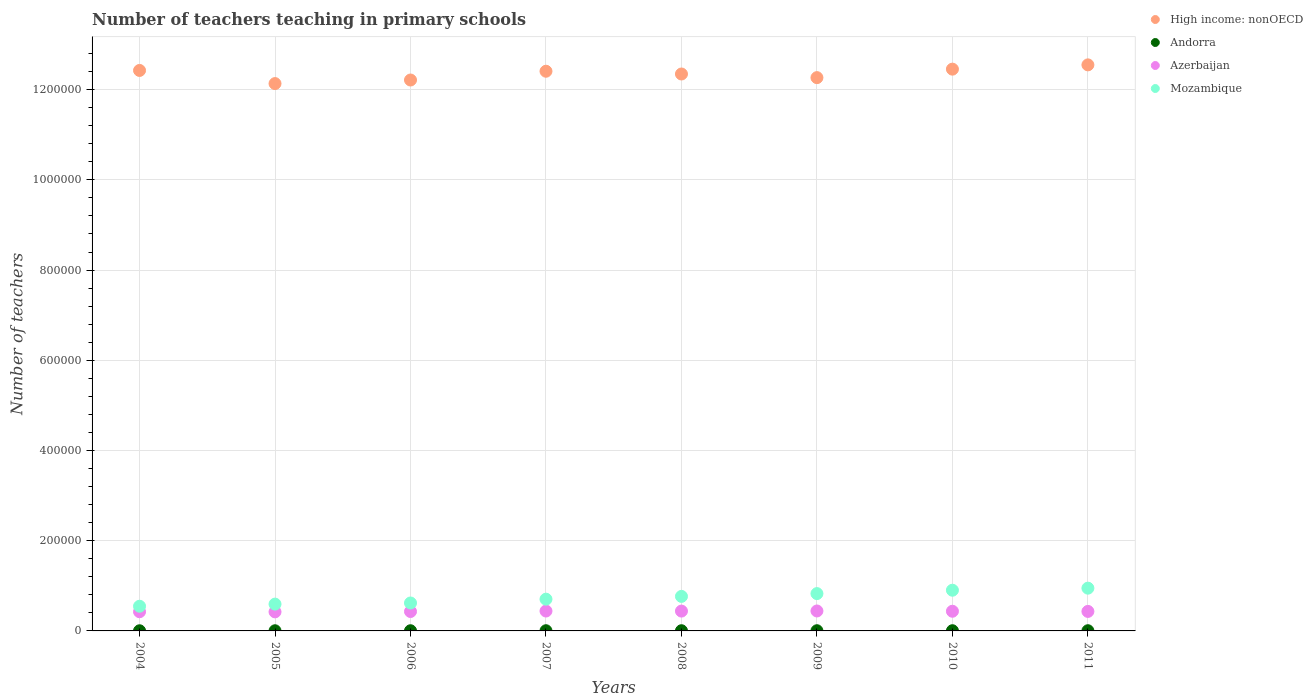How many different coloured dotlines are there?
Provide a short and direct response. 4. Is the number of dotlines equal to the number of legend labels?
Your response must be concise. Yes. What is the number of teachers teaching in primary schools in High income: nonOECD in 2010?
Offer a very short reply. 1.25e+06. Across all years, what is the maximum number of teachers teaching in primary schools in Andorra?
Provide a short and direct response. 453. Across all years, what is the minimum number of teachers teaching in primary schools in Andorra?
Your answer should be compact. 337. In which year was the number of teachers teaching in primary schools in Azerbaijan maximum?
Your answer should be very brief. 2009. In which year was the number of teachers teaching in primary schools in Mozambique minimum?
Provide a succinct answer. 2004. What is the total number of teachers teaching in primary schools in High income: nonOECD in the graph?
Offer a terse response. 9.88e+06. What is the difference between the number of teachers teaching in primary schools in High income: nonOECD in 2005 and that in 2009?
Provide a succinct answer. -1.32e+04. What is the difference between the number of teachers teaching in primary schools in Andorra in 2006 and the number of teachers teaching in primary schools in Azerbaijan in 2004?
Offer a very short reply. -4.21e+04. What is the average number of teachers teaching in primary schools in Azerbaijan per year?
Provide a short and direct response. 4.34e+04. In the year 2007, what is the difference between the number of teachers teaching in primary schools in Mozambique and number of teachers teaching in primary schools in Azerbaijan?
Provide a succinct answer. 2.63e+04. What is the ratio of the number of teachers teaching in primary schools in Azerbaijan in 2004 to that in 2007?
Your answer should be compact. 0.96. What is the difference between the highest and the second highest number of teachers teaching in primary schools in Azerbaijan?
Ensure brevity in your answer.  126. What is the difference between the highest and the lowest number of teachers teaching in primary schools in Andorra?
Your answer should be very brief. 116. Is the sum of the number of teachers teaching in primary schools in Azerbaijan in 2008 and 2009 greater than the maximum number of teachers teaching in primary schools in Andorra across all years?
Your answer should be very brief. Yes. Does the number of teachers teaching in primary schools in Andorra monotonically increase over the years?
Provide a succinct answer. No. Is the number of teachers teaching in primary schools in High income: nonOECD strictly greater than the number of teachers teaching in primary schools in Azerbaijan over the years?
Offer a terse response. Yes. Does the graph contain any zero values?
Offer a very short reply. No. How are the legend labels stacked?
Your response must be concise. Vertical. What is the title of the graph?
Your answer should be compact. Number of teachers teaching in primary schools. What is the label or title of the Y-axis?
Offer a very short reply. Number of teachers. What is the Number of teachers of High income: nonOECD in 2004?
Provide a short and direct response. 1.24e+06. What is the Number of teachers in Andorra in 2004?
Provide a succinct answer. 337. What is the Number of teachers in Azerbaijan in 2004?
Provide a succinct answer. 4.25e+04. What is the Number of teachers of Mozambique in 2004?
Offer a very short reply. 5.47e+04. What is the Number of teachers in High income: nonOECD in 2005?
Offer a very short reply. 1.21e+06. What is the Number of teachers in Andorra in 2005?
Offer a very short reply. 356. What is the Number of teachers of Azerbaijan in 2005?
Provide a short and direct response. 4.22e+04. What is the Number of teachers of Mozambique in 2005?
Offer a very short reply. 5.94e+04. What is the Number of teachers of High income: nonOECD in 2006?
Your response must be concise. 1.22e+06. What is the Number of teachers in Andorra in 2006?
Provide a succinct answer. 413. What is the Number of teachers of Azerbaijan in 2006?
Keep it short and to the point. 4.30e+04. What is the Number of teachers of Mozambique in 2006?
Your response must be concise. 6.19e+04. What is the Number of teachers of High income: nonOECD in 2007?
Ensure brevity in your answer.  1.24e+06. What is the Number of teachers in Andorra in 2007?
Ensure brevity in your answer.  432. What is the Number of teachers in Azerbaijan in 2007?
Make the answer very short. 4.41e+04. What is the Number of teachers of Mozambique in 2007?
Your answer should be compact. 7.04e+04. What is the Number of teachers in High income: nonOECD in 2008?
Provide a short and direct response. 1.23e+06. What is the Number of teachers of Andorra in 2008?
Offer a terse response. 448. What is the Number of teachers in Azerbaijan in 2008?
Your answer should be compact. 4.40e+04. What is the Number of teachers in Mozambique in 2008?
Your answer should be compact. 7.66e+04. What is the Number of teachers of High income: nonOECD in 2009?
Your response must be concise. 1.23e+06. What is the Number of teachers in Andorra in 2009?
Offer a terse response. 433. What is the Number of teachers in Azerbaijan in 2009?
Provide a succinct answer. 4.42e+04. What is the Number of teachers of Mozambique in 2009?
Offer a terse response. 8.28e+04. What is the Number of teachers in High income: nonOECD in 2010?
Give a very brief answer. 1.25e+06. What is the Number of teachers of Andorra in 2010?
Your response must be concise. 453. What is the Number of teachers in Azerbaijan in 2010?
Make the answer very short. 4.36e+04. What is the Number of teachers of Mozambique in 2010?
Offer a terse response. 9.02e+04. What is the Number of teachers of High income: nonOECD in 2011?
Your answer should be very brief. 1.25e+06. What is the Number of teachers of Andorra in 2011?
Your answer should be compact. 433. What is the Number of teachers in Azerbaijan in 2011?
Your answer should be compact. 4.32e+04. What is the Number of teachers in Mozambique in 2011?
Offer a terse response. 9.48e+04. Across all years, what is the maximum Number of teachers of High income: nonOECD?
Provide a short and direct response. 1.25e+06. Across all years, what is the maximum Number of teachers in Andorra?
Your response must be concise. 453. Across all years, what is the maximum Number of teachers in Azerbaijan?
Make the answer very short. 4.42e+04. Across all years, what is the maximum Number of teachers in Mozambique?
Your answer should be very brief. 9.48e+04. Across all years, what is the minimum Number of teachers in High income: nonOECD?
Offer a terse response. 1.21e+06. Across all years, what is the minimum Number of teachers of Andorra?
Keep it short and to the point. 337. Across all years, what is the minimum Number of teachers of Azerbaijan?
Provide a short and direct response. 4.22e+04. Across all years, what is the minimum Number of teachers in Mozambique?
Provide a short and direct response. 5.47e+04. What is the total Number of teachers in High income: nonOECD in the graph?
Provide a succinct answer. 9.88e+06. What is the total Number of teachers in Andorra in the graph?
Your response must be concise. 3305. What is the total Number of teachers in Azerbaijan in the graph?
Provide a short and direct response. 3.47e+05. What is the total Number of teachers of Mozambique in the graph?
Your answer should be compact. 5.91e+05. What is the difference between the Number of teachers of High income: nonOECD in 2004 and that in 2005?
Your response must be concise. 2.91e+04. What is the difference between the Number of teachers in Azerbaijan in 2004 and that in 2005?
Your response must be concise. 290. What is the difference between the Number of teachers in Mozambique in 2004 and that in 2005?
Your answer should be very brief. -4713. What is the difference between the Number of teachers of High income: nonOECD in 2004 and that in 2006?
Provide a succinct answer. 2.12e+04. What is the difference between the Number of teachers in Andorra in 2004 and that in 2006?
Make the answer very short. -76. What is the difference between the Number of teachers in Azerbaijan in 2004 and that in 2006?
Keep it short and to the point. -493. What is the difference between the Number of teachers in Mozambique in 2004 and that in 2006?
Provide a succinct answer. -7211. What is the difference between the Number of teachers of High income: nonOECD in 2004 and that in 2007?
Give a very brief answer. 1755. What is the difference between the Number of teachers in Andorra in 2004 and that in 2007?
Provide a succinct answer. -95. What is the difference between the Number of teachers of Azerbaijan in 2004 and that in 2007?
Offer a terse response. -1573. What is the difference between the Number of teachers of Mozambique in 2004 and that in 2007?
Provide a succinct answer. -1.57e+04. What is the difference between the Number of teachers of High income: nonOECD in 2004 and that in 2008?
Your response must be concise. 7879. What is the difference between the Number of teachers in Andorra in 2004 and that in 2008?
Keep it short and to the point. -111. What is the difference between the Number of teachers in Azerbaijan in 2004 and that in 2008?
Your answer should be very brief. -1438. What is the difference between the Number of teachers in Mozambique in 2004 and that in 2008?
Your response must be concise. -2.18e+04. What is the difference between the Number of teachers of High income: nonOECD in 2004 and that in 2009?
Offer a very short reply. 1.59e+04. What is the difference between the Number of teachers of Andorra in 2004 and that in 2009?
Provide a succinct answer. -96. What is the difference between the Number of teachers of Azerbaijan in 2004 and that in 2009?
Provide a succinct answer. -1699. What is the difference between the Number of teachers in Mozambique in 2004 and that in 2009?
Your response must be concise. -2.80e+04. What is the difference between the Number of teachers in High income: nonOECD in 2004 and that in 2010?
Your answer should be compact. -2881.5. What is the difference between the Number of teachers of Andorra in 2004 and that in 2010?
Provide a succinct answer. -116. What is the difference between the Number of teachers in Azerbaijan in 2004 and that in 2010?
Provide a succinct answer. -1077. What is the difference between the Number of teachers of Mozambique in 2004 and that in 2010?
Offer a very short reply. -3.55e+04. What is the difference between the Number of teachers in High income: nonOECD in 2004 and that in 2011?
Provide a short and direct response. -1.24e+04. What is the difference between the Number of teachers in Andorra in 2004 and that in 2011?
Provide a short and direct response. -96. What is the difference between the Number of teachers in Azerbaijan in 2004 and that in 2011?
Keep it short and to the point. -709. What is the difference between the Number of teachers in Mozambique in 2004 and that in 2011?
Your answer should be compact. -4.01e+04. What is the difference between the Number of teachers of High income: nonOECD in 2005 and that in 2006?
Make the answer very short. -7904.5. What is the difference between the Number of teachers of Andorra in 2005 and that in 2006?
Offer a very short reply. -57. What is the difference between the Number of teachers of Azerbaijan in 2005 and that in 2006?
Offer a very short reply. -783. What is the difference between the Number of teachers of Mozambique in 2005 and that in 2006?
Your answer should be very brief. -2498. What is the difference between the Number of teachers in High income: nonOECD in 2005 and that in 2007?
Your answer should be compact. -2.74e+04. What is the difference between the Number of teachers of Andorra in 2005 and that in 2007?
Give a very brief answer. -76. What is the difference between the Number of teachers of Azerbaijan in 2005 and that in 2007?
Ensure brevity in your answer.  -1863. What is the difference between the Number of teachers in Mozambique in 2005 and that in 2007?
Your response must be concise. -1.10e+04. What is the difference between the Number of teachers in High income: nonOECD in 2005 and that in 2008?
Your answer should be compact. -2.12e+04. What is the difference between the Number of teachers in Andorra in 2005 and that in 2008?
Give a very brief answer. -92. What is the difference between the Number of teachers in Azerbaijan in 2005 and that in 2008?
Provide a short and direct response. -1728. What is the difference between the Number of teachers of Mozambique in 2005 and that in 2008?
Your answer should be very brief. -1.71e+04. What is the difference between the Number of teachers in High income: nonOECD in 2005 and that in 2009?
Provide a short and direct response. -1.32e+04. What is the difference between the Number of teachers in Andorra in 2005 and that in 2009?
Your answer should be very brief. -77. What is the difference between the Number of teachers of Azerbaijan in 2005 and that in 2009?
Your answer should be compact. -1989. What is the difference between the Number of teachers of Mozambique in 2005 and that in 2009?
Your answer should be very brief. -2.33e+04. What is the difference between the Number of teachers of High income: nonOECD in 2005 and that in 2010?
Ensure brevity in your answer.  -3.20e+04. What is the difference between the Number of teachers in Andorra in 2005 and that in 2010?
Provide a succinct answer. -97. What is the difference between the Number of teachers in Azerbaijan in 2005 and that in 2010?
Provide a short and direct response. -1367. What is the difference between the Number of teachers in Mozambique in 2005 and that in 2010?
Your answer should be very brief. -3.08e+04. What is the difference between the Number of teachers in High income: nonOECD in 2005 and that in 2011?
Provide a short and direct response. -4.15e+04. What is the difference between the Number of teachers of Andorra in 2005 and that in 2011?
Make the answer very short. -77. What is the difference between the Number of teachers of Azerbaijan in 2005 and that in 2011?
Your answer should be very brief. -999. What is the difference between the Number of teachers in Mozambique in 2005 and that in 2011?
Give a very brief answer. -3.54e+04. What is the difference between the Number of teachers in High income: nonOECD in 2006 and that in 2007?
Your answer should be compact. -1.95e+04. What is the difference between the Number of teachers in Andorra in 2006 and that in 2007?
Offer a terse response. -19. What is the difference between the Number of teachers of Azerbaijan in 2006 and that in 2007?
Ensure brevity in your answer.  -1080. What is the difference between the Number of teachers in Mozambique in 2006 and that in 2007?
Offer a terse response. -8457. What is the difference between the Number of teachers in High income: nonOECD in 2006 and that in 2008?
Your response must be concise. -1.33e+04. What is the difference between the Number of teachers in Andorra in 2006 and that in 2008?
Ensure brevity in your answer.  -35. What is the difference between the Number of teachers of Azerbaijan in 2006 and that in 2008?
Your answer should be very brief. -945. What is the difference between the Number of teachers in Mozambique in 2006 and that in 2008?
Your response must be concise. -1.46e+04. What is the difference between the Number of teachers of High income: nonOECD in 2006 and that in 2009?
Ensure brevity in your answer.  -5290.12. What is the difference between the Number of teachers in Andorra in 2006 and that in 2009?
Provide a short and direct response. -20. What is the difference between the Number of teachers in Azerbaijan in 2006 and that in 2009?
Ensure brevity in your answer.  -1206. What is the difference between the Number of teachers in Mozambique in 2006 and that in 2009?
Ensure brevity in your answer.  -2.08e+04. What is the difference between the Number of teachers of High income: nonOECD in 2006 and that in 2010?
Make the answer very short. -2.41e+04. What is the difference between the Number of teachers of Azerbaijan in 2006 and that in 2010?
Offer a terse response. -584. What is the difference between the Number of teachers in Mozambique in 2006 and that in 2010?
Your answer should be very brief. -2.83e+04. What is the difference between the Number of teachers of High income: nonOECD in 2006 and that in 2011?
Give a very brief answer. -3.36e+04. What is the difference between the Number of teachers in Andorra in 2006 and that in 2011?
Provide a succinct answer. -20. What is the difference between the Number of teachers of Azerbaijan in 2006 and that in 2011?
Offer a very short reply. -216. What is the difference between the Number of teachers in Mozambique in 2006 and that in 2011?
Your response must be concise. -3.29e+04. What is the difference between the Number of teachers of High income: nonOECD in 2007 and that in 2008?
Offer a very short reply. 6124. What is the difference between the Number of teachers in Andorra in 2007 and that in 2008?
Your answer should be very brief. -16. What is the difference between the Number of teachers in Azerbaijan in 2007 and that in 2008?
Your response must be concise. 135. What is the difference between the Number of teachers in Mozambique in 2007 and that in 2008?
Your answer should be very brief. -6169. What is the difference between the Number of teachers in High income: nonOECD in 2007 and that in 2009?
Offer a very short reply. 1.42e+04. What is the difference between the Number of teachers of Andorra in 2007 and that in 2009?
Your answer should be compact. -1. What is the difference between the Number of teachers of Azerbaijan in 2007 and that in 2009?
Give a very brief answer. -126. What is the difference between the Number of teachers of Mozambique in 2007 and that in 2009?
Offer a very short reply. -1.24e+04. What is the difference between the Number of teachers of High income: nonOECD in 2007 and that in 2010?
Keep it short and to the point. -4636.5. What is the difference between the Number of teachers in Andorra in 2007 and that in 2010?
Your response must be concise. -21. What is the difference between the Number of teachers of Azerbaijan in 2007 and that in 2010?
Your answer should be compact. 496. What is the difference between the Number of teachers of Mozambique in 2007 and that in 2010?
Make the answer very short. -1.98e+04. What is the difference between the Number of teachers in High income: nonOECD in 2007 and that in 2011?
Offer a terse response. -1.41e+04. What is the difference between the Number of teachers of Andorra in 2007 and that in 2011?
Give a very brief answer. -1. What is the difference between the Number of teachers of Azerbaijan in 2007 and that in 2011?
Keep it short and to the point. 864. What is the difference between the Number of teachers in Mozambique in 2007 and that in 2011?
Your answer should be compact. -2.44e+04. What is the difference between the Number of teachers in High income: nonOECD in 2008 and that in 2009?
Provide a succinct answer. 8044.75. What is the difference between the Number of teachers in Andorra in 2008 and that in 2009?
Your response must be concise. 15. What is the difference between the Number of teachers in Azerbaijan in 2008 and that in 2009?
Offer a very short reply. -261. What is the difference between the Number of teachers of Mozambique in 2008 and that in 2009?
Your response must be concise. -6195. What is the difference between the Number of teachers in High income: nonOECD in 2008 and that in 2010?
Your response must be concise. -1.08e+04. What is the difference between the Number of teachers of Azerbaijan in 2008 and that in 2010?
Your answer should be very brief. 361. What is the difference between the Number of teachers of Mozambique in 2008 and that in 2010?
Offer a terse response. -1.37e+04. What is the difference between the Number of teachers of High income: nonOECD in 2008 and that in 2011?
Your response must be concise. -2.02e+04. What is the difference between the Number of teachers in Azerbaijan in 2008 and that in 2011?
Your answer should be very brief. 729. What is the difference between the Number of teachers in Mozambique in 2008 and that in 2011?
Offer a terse response. -1.82e+04. What is the difference between the Number of teachers of High income: nonOECD in 2009 and that in 2010?
Keep it short and to the point. -1.88e+04. What is the difference between the Number of teachers of Andorra in 2009 and that in 2010?
Give a very brief answer. -20. What is the difference between the Number of teachers in Azerbaijan in 2009 and that in 2010?
Your answer should be very brief. 622. What is the difference between the Number of teachers in Mozambique in 2009 and that in 2010?
Give a very brief answer. -7483. What is the difference between the Number of teachers in High income: nonOECD in 2009 and that in 2011?
Your answer should be very brief. -2.83e+04. What is the difference between the Number of teachers in Azerbaijan in 2009 and that in 2011?
Keep it short and to the point. 990. What is the difference between the Number of teachers of Mozambique in 2009 and that in 2011?
Provide a short and direct response. -1.20e+04. What is the difference between the Number of teachers of High income: nonOECD in 2010 and that in 2011?
Provide a short and direct response. -9480.25. What is the difference between the Number of teachers of Andorra in 2010 and that in 2011?
Your answer should be very brief. 20. What is the difference between the Number of teachers in Azerbaijan in 2010 and that in 2011?
Provide a succinct answer. 368. What is the difference between the Number of teachers in Mozambique in 2010 and that in 2011?
Your answer should be very brief. -4562. What is the difference between the Number of teachers of High income: nonOECD in 2004 and the Number of teachers of Andorra in 2005?
Offer a terse response. 1.24e+06. What is the difference between the Number of teachers in High income: nonOECD in 2004 and the Number of teachers in Azerbaijan in 2005?
Provide a short and direct response. 1.20e+06. What is the difference between the Number of teachers of High income: nonOECD in 2004 and the Number of teachers of Mozambique in 2005?
Make the answer very short. 1.18e+06. What is the difference between the Number of teachers of Andorra in 2004 and the Number of teachers of Azerbaijan in 2005?
Ensure brevity in your answer.  -4.19e+04. What is the difference between the Number of teachers in Andorra in 2004 and the Number of teachers in Mozambique in 2005?
Your answer should be compact. -5.91e+04. What is the difference between the Number of teachers in Azerbaijan in 2004 and the Number of teachers in Mozambique in 2005?
Offer a very short reply. -1.69e+04. What is the difference between the Number of teachers of High income: nonOECD in 2004 and the Number of teachers of Andorra in 2006?
Give a very brief answer. 1.24e+06. What is the difference between the Number of teachers of High income: nonOECD in 2004 and the Number of teachers of Azerbaijan in 2006?
Keep it short and to the point. 1.20e+06. What is the difference between the Number of teachers of High income: nonOECD in 2004 and the Number of teachers of Mozambique in 2006?
Offer a very short reply. 1.18e+06. What is the difference between the Number of teachers of Andorra in 2004 and the Number of teachers of Azerbaijan in 2006?
Offer a terse response. -4.27e+04. What is the difference between the Number of teachers in Andorra in 2004 and the Number of teachers in Mozambique in 2006?
Offer a terse response. -6.16e+04. What is the difference between the Number of teachers of Azerbaijan in 2004 and the Number of teachers of Mozambique in 2006?
Keep it short and to the point. -1.94e+04. What is the difference between the Number of teachers in High income: nonOECD in 2004 and the Number of teachers in Andorra in 2007?
Give a very brief answer. 1.24e+06. What is the difference between the Number of teachers in High income: nonOECD in 2004 and the Number of teachers in Azerbaijan in 2007?
Make the answer very short. 1.20e+06. What is the difference between the Number of teachers of High income: nonOECD in 2004 and the Number of teachers of Mozambique in 2007?
Give a very brief answer. 1.17e+06. What is the difference between the Number of teachers of Andorra in 2004 and the Number of teachers of Azerbaijan in 2007?
Provide a succinct answer. -4.38e+04. What is the difference between the Number of teachers of Andorra in 2004 and the Number of teachers of Mozambique in 2007?
Make the answer very short. -7.01e+04. What is the difference between the Number of teachers of Azerbaijan in 2004 and the Number of teachers of Mozambique in 2007?
Give a very brief answer. -2.79e+04. What is the difference between the Number of teachers of High income: nonOECD in 2004 and the Number of teachers of Andorra in 2008?
Provide a short and direct response. 1.24e+06. What is the difference between the Number of teachers in High income: nonOECD in 2004 and the Number of teachers in Azerbaijan in 2008?
Your answer should be very brief. 1.20e+06. What is the difference between the Number of teachers in High income: nonOECD in 2004 and the Number of teachers in Mozambique in 2008?
Offer a very short reply. 1.17e+06. What is the difference between the Number of teachers of Andorra in 2004 and the Number of teachers of Azerbaijan in 2008?
Provide a succinct answer. -4.36e+04. What is the difference between the Number of teachers of Andorra in 2004 and the Number of teachers of Mozambique in 2008?
Ensure brevity in your answer.  -7.62e+04. What is the difference between the Number of teachers in Azerbaijan in 2004 and the Number of teachers in Mozambique in 2008?
Keep it short and to the point. -3.40e+04. What is the difference between the Number of teachers of High income: nonOECD in 2004 and the Number of teachers of Andorra in 2009?
Keep it short and to the point. 1.24e+06. What is the difference between the Number of teachers of High income: nonOECD in 2004 and the Number of teachers of Azerbaijan in 2009?
Offer a terse response. 1.20e+06. What is the difference between the Number of teachers of High income: nonOECD in 2004 and the Number of teachers of Mozambique in 2009?
Keep it short and to the point. 1.16e+06. What is the difference between the Number of teachers in Andorra in 2004 and the Number of teachers in Azerbaijan in 2009?
Provide a short and direct response. -4.39e+04. What is the difference between the Number of teachers in Andorra in 2004 and the Number of teachers in Mozambique in 2009?
Your response must be concise. -8.24e+04. What is the difference between the Number of teachers of Azerbaijan in 2004 and the Number of teachers of Mozambique in 2009?
Offer a very short reply. -4.02e+04. What is the difference between the Number of teachers of High income: nonOECD in 2004 and the Number of teachers of Andorra in 2010?
Offer a very short reply. 1.24e+06. What is the difference between the Number of teachers of High income: nonOECD in 2004 and the Number of teachers of Azerbaijan in 2010?
Offer a very short reply. 1.20e+06. What is the difference between the Number of teachers in High income: nonOECD in 2004 and the Number of teachers in Mozambique in 2010?
Your answer should be very brief. 1.15e+06. What is the difference between the Number of teachers in Andorra in 2004 and the Number of teachers in Azerbaijan in 2010?
Offer a terse response. -4.33e+04. What is the difference between the Number of teachers of Andorra in 2004 and the Number of teachers of Mozambique in 2010?
Make the answer very short. -8.99e+04. What is the difference between the Number of teachers of Azerbaijan in 2004 and the Number of teachers of Mozambique in 2010?
Your answer should be very brief. -4.77e+04. What is the difference between the Number of teachers in High income: nonOECD in 2004 and the Number of teachers in Andorra in 2011?
Offer a terse response. 1.24e+06. What is the difference between the Number of teachers in High income: nonOECD in 2004 and the Number of teachers in Azerbaijan in 2011?
Offer a very short reply. 1.20e+06. What is the difference between the Number of teachers in High income: nonOECD in 2004 and the Number of teachers in Mozambique in 2011?
Offer a very short reply. 1.15e+06. What is the difference between the Number of teachers of Andorra in 2004 and the Number of teachers of Azerbaijan in 2011?
Your answer should be compact. -4.29e+04. What is the difference between the Number of teachers of Andorra in 2004 and the Number of teachers of Mozambique in 2011?
Keep it short and to the point. -9.45e+04. What is the difference between the Number of teachers in Azerbaijan in 2004 and the Number of teachers in Mozambique in 2011?
Provide a succinct answer. -5.23e+04. What is the difference between the Number of teachers of High income: nonOECD in 2005 and the Number of teachers of Andorra in 2006?
Offer a terse response. 1.21e+06. What is the difference between the Number of teachers of High income: nonOECD in 2005 and the Number of teachers of Azerbaijan in 2006?
Give a very brief answer. 1.17e+06. What is the difference between the Number of teachers of High income: nonOECD in 2005 and the Number of teachers of Mozambique in 2006?
Offer a very short reply. 1.15e+06. What is the difference between the Number of teachers in Andorra in 2005 and the Number of teachers in Azerbaijan in 2006?
Your answer should be compact. -4.27e+04. What is the difference between the Number of teachers in Andorra in 2005 and the Number of teachers in Mozambique in 2006?
Make the answer very short. -6.16e+04. What is the difference between the Number of teachers in Azerbaijan in 2005 and the Number of teachers in Mozambique in 2006?
Your response must be concise. -1.97e+04. What is the difference between the Number of teachers in High income: nonOECD in 2005 and the Number of teachers in Andorra in 2007?
Provide a succinct answer. 1.21e+06. What is the difference between the Number of teachers in High income: nonOECD in 2005 and the Number of teachers in Azerbaijan in 2007?
Your answer should be very brief. 1.17e+06. What is the difference between the Number of teachers of High income: nonOECD in 2005 and the Number of teachers of Mozambique in 2007?
Offer a very short reply. 1.14e+06. What is the difference between the Number of teachers in Andorra in 2005 and the Number of teachers in Azerbaijan in 2007?
Provide a succinct answer. -4.38e+04. What is the difference between the Number of teachers in Andorra in 2005 and the Number of teachers in Mozambique in 2007?
Your answer should be very brief. -7.00e+04. What is the difference between the Number of teachers in Azerbaijan in 2005 and the Number of teachers in Mozambique in 2007?
Offer a terse response. -2.81e+04. What is the difference between the Number of teachers of High income: nonOECD in 2005 and the Number of teachers of Andorra in 2008?
Provide a short and direct response. 1.21e+06. What is the difference between the Number of teachers in High income: nonOECD in 2005 and the Number of teachers in Azerbaijan in 2008?
Ensure brevity in your answer.  1.17e+06. What is the difference between the Number of teachers in High income: nonOECD in 2005 and the Number of teachers in Mozambique in 2008?
Offer a terse response. 1.14e+06. What is the difference between the Number of teachers in Andorra in 2005 and the Number of teachers in Azerbaijan in 2008?
Ensure brevity in your answer.  -4.36e+04. What is the difference between the Number of teachers of Andorra in 2005 and the Number of teachers of Mozambique in 2008?
Offer a very short reply. -7.62e+04. What is the difference between the Number of teachers of Azerbaijan in 2005 and the Number of teachers of Mozambique in 2008?
Your answer should be compact. -3.43e+04. What is the difference between the Number of teachers in High income: nonOECD in 2005 and the Number of teachers in Andorra in 2009?
Provide a succinct answer. 1.21e+06. What is the difference between the Number of teachers of High income: nonOECD in 2005 and the Number of teachers of Azerbaijan in 2009?
Provide a short and direct response. 1.17e+06. What is the difference between the Number of teachers in High income: nonOECD in 2005 and the Number of teachers in Mozambique in 2009?
Provide a short and direct response. 1.13e+06. What is the difference between the Number of teachers of Andorra in 2005 and the Number of teachers of Azerbaijan in 2009?
Your response must be concise. -4.39e+04. What is the difference between the Number of teachers of Andorra in 2005 and the Number of teachers of Mozambique in 2009?
Keep it short and to the point. -8.24e+04. What is the difference between the Number of teachers in Azerbaijan in 2005 and the Number of teachers in Mozambique in 2009?
Keep it short and to the point. -4.05e+04. What is the difference between the Number of teachers of High income: nonOECD in 2005 and the Number of teachers of Andorra in 2010?
Ensure brevity in your answer.  1.21e+06. What is the difference between the Number of teachers of High income: nonOECD in 2005 and the Number of teachers of Azerbaijan in 2010?
Your answer should be very brief. 1.17e+06. What is the difference between the Number of teachers of High income: nonOECD in 2005 and the Number of teachers of Mozambique in 2010?
Your response must be concise. 1.12e+06. What is the difference between the Number of teachers in Andorra in 2005 and the Number of teachers in Azerbaijan in 2010?
Your response must be concise. -4.33e+04. What is the difference between the Number of teachers in Andorra in 2005 and the Number of teachers in Mozambique in 2010?
Keep it short and to the point. -8.99e+04. What is the difference between the Number of teachers of Azerbaijan in 2005 and the Number of teachers of Mozambique in 2010?
Make the answer very short. -4.80e+04. What is the difference between the Number of teachers in High income: nonOECD in 2005 and the Number of teachers in Andorra in 2011?
Provide a succinct answer. 1.21e+06. What is the difference between the Number of teachers in High income: nonOECD in 2005 and the Number of teachers in Azerbaijan in 2011?
Give a very brief answer. 1.17e+06. What is the difference between the Number of teachers in High income: nonOECD in 2005 and the Number of teachers in Mozambique in 2011?
Keep it short and to the point. 1.12e+06. What is the difference between the Number of teachers in Andorra in 2005 and the Number of teachers in Azerbaijan in 2011?
Keep it short and to the point. -4.29e+04. What is the difference between the Number of teachers in Andorra in 2005 and the Number of teachers in Mozambique in 2011?
Make the answer very short. -9.44e+04. What is the difference between the Number of teachers of Azerbaijan in 2005 and the Number of teachers of Mozambique in 2011?
Keep it short and to the point. -5.26e+04. What is the difference between the Number of teachers of High income: nonOECD in 2006 and the Number of teachers of Andorra in 2007?
Give a very brief answer. 1.22e+06. What is the difference between the Number of teachers of High income: nonOECD in 2006 and the Number of teachers of Azerbaijan in 2007?
Ensure brevity in your answer.  1.18e+06. What is the difference between the Number of teachers in High income: nonOECD in 2006 and the Number of teachers in Mozambique in 2007?
Provide a succinct answer. 1.15e+06. What is the difference between the Number of teachers in Andorra in 2006 and the Number of teachers in Azerbaijan in 2007?
Your answer should be compact. -4.37e+04. What is the difference between the Number of teachers in Andorra in 2006 and the Number of teachers in Mozambique in 2007?
Ensure brevity in your answer.  -7.00e+04. What is the difference between the Number of teachers of Azerbaijan in 2006 and the Number of teachers of Mozambique in 2007?
Give a very brief answer. -2.74e+04. What is the difference between the Number of teachers in High income: nonOECD in 2006 and the Number of teachers in Andorra in 2008?
Keep it short and to the point. 1.22e+06. What is the difference between the Number of teachers of High income: nonOECD in 2006 and the Number of teachers of Azerbaijan in 2008?
Keep it short and to the point. 1.18e+06. What is the difference between the Number of teachers of High income: nonOECD in 2006 and the Number of teachers of Mozambique in 2008?
Offer a terse response. 1.14e+06. What is the difference between the Number of teachers in Andorra in 2006 and the Number of teachers in Azerbaijan in 2008?
Your answer should be compact. -4.36e+04. What is the difference between the Number of teachers of Andorra in 2006 and the Number of teachers of Mozambique in 2008?
Ensure brevity in your answer.  -7.61e+04. What is the difference between the Number of teachers of Azerbaijan in 2006 and the Number of teachers of Mozambique in 2008?
Keep it short and to the point. -3.35e+04. What is the difference between the Number of teachers of High income: nonOECD in 2006 and the Number of teachers of Andorra in 2009?
Your response must be concise. 1.22e+06. What is the difference between the Number of teachers of High income: nonOECD in 2006 and the Number of teachers of Azerbaijan in 2009?
Offer a terse response. 1.18e+06. What is the difference between the Number of teachers of High income: nonOECD in 2006 and the Number of teachers of Mozambique in 2009?
Provide a succinct answer. 1.14e+06. What is the difference between the Number of teachers of Andorra in 2006 and the Number of teachers of Azerbaijan in 2009?
Offer a terse response. -4.38e+04. What is the difference between the Number of teachers in Andorra in 2006 and the Number of teachers in Mozambique in 2009?
Your answer should be very brief. -8.23e+04. What is the difference between the Number of teachers of Azerbaijan in 2006 and the Number of teachers of Mozambique in 2009?
Give a very brief answer. -3.97e+04. What is the difference between the Number of teachers of High income: nonOECD in 2006 and the Number of teachers of Andorra in 2010?
Provide a succinct answer. 1.22e+06. What is the difference between the Number of teachers of High income: nonOECD in 2006 and the Number of teachers of Azerbaijan in 2010?
Offer a terse response. 1.18e+06. What is the difference between the Number of teachers in High income: nonOECD in 2006 and the Number of teachers in Mozambique in 2010?
Offer a terse response. 1.13e+06. What is the difference between the Number of teachers of Andorra in 2006 and the Number of teachers of Azerbaijan in 2010?
Your answer should be compact. -4.32e+04. What is the difference between the Number of teachers of Andorra in 2006 and the Number of teachers of Mozambique in 2010?
Make the answer very short. -8.98e+04. What is the difference between the Number of teachers of Azerbaijan in 2006 and the Number of teachers of Mozambique in 2010?
Give a very brief answer. -4.72e+04. What is the difference between the Number of teachers in High income: nonOECD in 2006 and the Number of teachers in Andorra in 2011?
Make the answer very short. 1.22e+06. What is the difference between the Number of teachers in High income: nonOECD in 2006 and the Number of teachers in Azerbaijan in 2011?
Your answer should be very brief. 1.18e+06. What is the difference between the Number of teachers in High income: nonOECD in 2006 and the Number of teachers in Mozambique in 2011?
Offer a very short reply. 1.13e+06. What is the difference between the Number of teachers of Andorra in 2006 and the Number of teachers of Azerbaijan in 2011?
Provide a succinct answer. -4.28e+04. What is the difference between the Number of teachers in Andorra in 2006 and the Number of teachers in Mozambique in 2011?
Your answer should be very brief. -9.44e+04. What is the difference between the Number of teachers in Azerbaijan in 2006 and the Number of teachers in Mozambique in 2011?
Provide a short and direct response. -5.18e+04. What is the difference between the Number of teachers of High income: nonOECD in 2007 and the Number of teachers of Andorra in 2008?
Your answer should be very brief. 1.24e+06. What is the difference between the Number of teachers of High income: nonOECD in 2007 and the Number of teachers of Azerbaijan in 2008?
Offer a very short reply. 1.20e+06. What is the difference between the Number of teachers of High income: nonOECD in 2007 and the Number of teachers of Mozambique in 2008?
Provide a short and direct response. 1.16e+06. What is the difference between the Number of teachers of Andorra in 2007 and the Number of teachers of Azerbaijan in 2008?
Provide a succinct answer. -4.35e+04. What is the difference between the Number of teachers in Andorra in 2007 and the Number of teachers in Mozambique in 2008?
Offer a very short reply. -7.61e+04. What is the difference between the Number of teachers of Azerbaijan in 2007 and the Number of teachers of Mozambique in 2008?
Ensure brevity in your answer.  -3.25e+04. What is the difference between the Number of teachers of High income: nonOECD in 2007 and the Number of teachers of Andorra in 2009?
Offer a very short reply. 1.24e+06. What is the difference between the Number of teachers in High income: nonOECD in 2007 and the Number of teachers in Azerbaijan in 2009?
Offer a terse response. 1.20e+06. What is the difference between the Number of teachers in High income: nonOECD in 2007 and the Number of teachers in Mozambique in 2009?
Ensure brevity in your answer.  1.16e+06. What is the difference between the Number of teachers of Andorra in 2007 and the Number of teachers of Azerbaijan in 2009?
Your answer should be very brief. -4.38e+04. What is the difference between the Number of teachers in Andorra in 2007 and the Number of teachers in Mozambique in 2009?
Ensure brevity in your answer.  -8.23e+04. What is the difference between the Number of teachers in Azerbaijan in 2007 and the Number of teachers in Mozambique in 2009?
Give a very brief answer. -3.86e+04. What is the difference between the Number of teachers in High income: nonOECD in 2007 and the Number of teachers in Andorra in 2010?
Your answer should be compact. 1.24e+06. What is the difference between the Number of teachers in High income: nonOECD in 2007 and the Number of teachers in Azerbaijan in 2010?
Your response must be concise. 1.20e+06. What is the difference between the Number of teachers of High income: nonOECD in 2007 and the Number of teachers of Mozambique in 2010?
Keep it short and to the point. 1.15e+06. What is the difference between the Number of teachers in Andorra in 2007 and the Number of teachers in Azerbaijan in 2010?
Keep it short and to the point. -4.32e+04. What is the difference between the Number of teachers in Andorra in 2007 and the Number of teachers in Mozambique in 2010?
Offer a terse response. -8.98e+04. What is the difference between the Number of teachers in Azerbaijan in 2007 and the Number of teachers in Mozambique in 2010?
Your response must be concise. -4.61e+04. What is the difference between the Number of teachers in High income: nonOECD in 2007 and the Number of teachers in Andorra in 2011?
Provide a succinct answer. 1.24e+06. What is the difference between the Number of teachers in High income: nonOECD in 2007 and the Number of teachers in Azerbaijan in 2011?
Offer a very short reply. 1.20e+06. What is the difference between the Number of teachers in High income: nonOECD in 2007 and the Number of teachers in Mozambique in 2011?
Keep it short and to the point. 1.15e+06. What is the difference between the Number of teachers of Andorra in 2007 and the Number of teachers of Azerbaijan in 2011?
Your answer should be compact. -4.28e+04. What is the difference between the Number of teachers of Andorra in 2007 and the Number of teachers of Mozambique in 2011?
Your answer should be very brief. -9.44e+04. What is the difference between the Number of teachers in Azerbaijan in 2007 and the Number of teachers in Mozambique in 2011?
Offer a terse response. -5.07e+04. What is the difference between the Number of teachers of High income: nonOECD in 2008 and the Number of teachers of Andorra in 2009?
Your response must be concise. 1.23e+06. What is the difference between the Number of teachers of High income: nonOECD in 2008 and the Number of teachers of Azerbaijan in 2009?
Your answer should be compact. 1.19e+06. What is the difference between the Number of teachers in High income: nonOECD in 2008 and the Number of teachers in Mozambique in 2009?
Provide a short and direct response. 1.15e+06. What is the difference between the Number of teachers of Andorra in 2008 and the Number of teachers of Azerbaijan in 2009?
Your answer should be compact. -4.38e+04. What is the difference between the Number of teachers of Andorra in 2008 and the Number of teachers of Mozambique in 2009?
Offer a terse response. -8.23e+04. What is the difference between the Number of teachers in Azerbaijan in 2008 and the Number of teachers in Mozambique in 2009?
Your answer should be very brief. -3.88e+04. What is the difference between the Number of teachers in High income: nonOECD in 2008 and the Number of teachers in Andorra in 2010?
Offer a terse response. 1.23e+06. What is the difference between the Number of teachers in High income: nonOECD in 2008 and the Number of teachers in Azerbaijan in 2010?
Offer a terse response. 1.19e+06. What is the difference between the Number of teachers of High income: nonOECD in 2008 and the Number of teachers of Mozambique in 2010?
Make the answer very short. 1.14e+06. What is the difference between the Number of teachers in Andorra in 2008 and the Number of teachers in Azerbaijan in 2010?
Ensure brevity in your answer.  -4.32e+04. What is the difference between the Number of teachers of Andorra in 2008 and the Number of teachers of Mozambique in 2010?
Provide a short and direct response. -8.98e+04. What is the difference between the Number of teachers of Azerbaijan in 2008 and the Number of teachers of Mozambique in 2010?
Offer a very short reply. -4.63e+04. What is the difference between the Number of teachers in High income: nonOECD in 2008 and the Number of teachers in Andorra in 2011?
Provide a short and direct response. 1.23e+06. What is the difference between the Number of teachers of High income: nonOECD in 2008 and the Number of teachers of Azerbaijan in 2011?
Your response must be concise. 1.19e+06. What is the difference between the Number of teachers in High income: nonOECD in 2008 and the Number of teachers in Mozambique in 2011?
Give a very brief answer. 1.14e+06. What is the difference between the Number of teachers in Andorra in 2008 and the Number of teachers in Azerbaijan in 2011?
Make the answer very short. -4.28e+04. What is the difference between the Number of teachers in Andorra in 2008 and the Number of teachers in Mozambique in 2011?
Your answer should be compact. -9.44e+04. What is the difference between the Number of teachers of Azerbaijan in 2008 and the Number of teachers of Mozambique in 2011?
Your response must be concise. -5.08e+04. What is the difference between the Number of teachers in High income: nonOECD in 2009 and the Number of teachers in Andorra in 2010?
Ensure brevity in your answer.  1.23e+06. What is the difference between the Number of teachers in High income: nonOECD in 2009 and the Number of teachers in Azerbaijan in 2010?
Provide a succinct answer. 1.18e+06. What is the difference between the Number of teachers in High income: nonOECD in 2009 and the Number of teachers in Mozambique in 2010?
Your answer should be very brief. 1.14e+06. What is the difference between the Number of teachers in Andorra in 2009 and the Number of teachers in Azerbaijan in 2010?
Ensure brevity in your answer.  -4.32e+04. What is the difference between the Number of teachers of Andorra in 2009 and the Number of teachers of Mozambique in 2010?
Offer a terse response. -8.98e+04. What is the difference between the Number of teachers of Azerbaijan in 2009 and the Number of teachers of Mozambique in 2010?
Offer a terse response. -4.60e+04. What is the difference between the Number of teachers in High income: nonOECD in 2009 and the Number of teachers in Andorra in 2011?
Ensure brevity in your answer.  1.23e+06. What is the difference between the Number of teachers in High income: nonOECD in 2009 and the Number of teachers in Azerbaijan in 2011?
Provide a short and direct response. 1.18e+06. What is the difference between the Number of teachers of High income: nonOECD in 2009 and the Number of teachers of Mozambique in 2011?
Provide a succinct answer. 1.13e+06. What is the difference between the Number of teachers in Andorra in 2009 and the Number of teachers in Azerbaijan in 2011?
Keep it short and to the point. -4.28e+04. What is the difference between the Number of teachers in Andorra in 2009 and the Number of teachers in Mozambique in 2011?
Provide a succinct answer. -9.44e+04. What is the difference between the Number of teachers in Azerbaijan in 2009 and the Number of teachers in Mozambique in 2011?
Make the answer very short. -5.06e+04. What is the difference between the Number of teachers in High income: nonOECD in 2010 and the Number of teachers in Andorra in 2011?
Your answer should be compact. 1.25e+06. What is the difference between the Number of teachers of High income: nonOECD in 2010 and the Number of teachers of Azerbaijan in 2011?
Your response must be concise. 1.20e+06. What is the difference between the Number of teachers of High income: nonOECD in 2010 and the Number of teachers of Mozambique in 2011?
Keep it short and to the point. 1.15e+06. What is the difference between the Number of teachers in Andorra in 2010 and the Number of teachers in Azerbaijan in 2011?
Keep it short and to the point. -4.28e+04. What is the difference between the Number of teachers of Andorra in 2010 and the Number of teachers of Mozambique in 2011?
Provide a short and direct response. -9.43e+04. What is the difference between the Number of teachers in Azerbaijan in 2010 and the Number of teachers in Mozambique in 2011?
Your answer should be very brief. -5.12e+04. What is the average Number of teachers in High income: nonOECD per year?
Ensure brevity in your answer.  1.23e+06. What is the average Number of teachers in Andorra per year?
Make the answer very short. 413.12. What is the average Number of teachers in Azerbaijan per year?
Ensure brevity in your answer.  4.34e+04. What is the average Number of teachers in Mozambique per year?
Provide a succinct answer. 7.39e+04. In the year 2004, what is the difference between the Number of teachers in High income: nonOECD and Number of teachers in Andorra?
Ensure brevity in your answer.  1.24e+06. In the year 2004, what is the difference between the Number of teachers in High income: nonOECD and Number of teachers in Azerbaijan?
Keep it short and to the point. 1.20e+06. In the year 2004, what is the difference between the Number of teachers in High income: nonOECD and Number of teachers in Mozambique?
Offer a very short reply. 1.19e+06. In the year 2004, what is the difference between the Number of teachers of Andorra and Number of teachers of Azerbaijan?
Offer a terse response. -4.22e+04. In the year 2004, what is the difference between the Number of teachers in Andorra and Number of teachers in Mozambique?
Your answer should be very brief. -5.44e+04. In the year 2004, what is the difference between the Number of teachers of Azerbaijan and Number of teachers of Mozambique?
Keep it short and to the point. -1.22e+04. In the year 2005, what is the difference between the Number of teachers in High income: nonOECD and Number of teachers in Andorra?
Your response must be concise. 1.21e+06. In the year 2005, what is the difference between the Number of teachers of High income: nonOECD and Number of teachers of Azerbaijan?
Provide a succinct answer. 1.17e+06. In the year 2005, what is the difference between the Number of teachers of High income: nonOECD and Number of teachers of Mozambique?
Make the answer very short. 1.15e+06. In the year 2005, what is the difference between the Number of teachers of Andorra and Number of teachers of Azerbaijan?
Offer a terse response. -4.19e+04. In the year 2005, what is the difference between the Number of teachers in Andorra and Number of teachers in Mozambique?
Provide a succinct answer. -5.91e+04. In the year 2005, what is the difference between the Number of teachers in Azerbaijan and Number of teachers in Mozambique?
Your response must be concise. -1.72e+04. In the year 2006, what is the difference between the Number of teachers of High income: nonOECD and Number of teachers of Andorra?
Offer a terse response. 1.22e+06. In the year 2006, what is the difference between the Number of teachers of High income: nonOECD and Number of teachers of Azerbaijan?
Offer a very short reply. 1.18e+06. In the year 2006, what is the difference between the Number of teachers of High income: nonOECD and Number of teachers of Mozambique?
Keep it short and to the point. 1.16e+06. In the year 2006, what is the difference between the Number of teachers in Andorra and Number of teachers in Azerbaijan?
Give a very brief answer. -4.26e+04. In the year 2006, what is the difference between the Number of teachers of Andorra and Number of teachers of Mozambique?
Offer a terse response. -6.15e+04. In the year 2006, what is the difference between the Number of teachers in Azerbaijan and Number of teachers in Mozambique?
Keep it short and to the point. -1.89e+04. In the year 2007, what is the difference between the Number of teachers of High income: nonOECD and Number of teachers of Andorra?
Provide a succinct answer. 1.24e+06. In the year 2007, what is the difference between the Number of teachers in High income: nonOECD and Number of teachers in Azerbaijan?
Your answer should be compact. 1.20e+06. In the year 2007, what is the difference between the Number of teachers in High income: nonOECD and Number of teachers in Mozambique?
Give a very brief answer. 1.17e+06. In the year 2007, what is the difference between the Number of teachers of Andorra and Number of teachers of Azerbaijan?
Provide a succinct answer. -4.37e+04. In the year 2007, what is the difference between the Number of teachers in Andorra and Number of teachers in Mozambique?
Give a very brief answer. -7.00e+04. In the year 2007, what is the difference between the Number of teachers in Azerbaijan and Number of teachers in Mozambique?
Your answer should be very brief. -2.63e+04. In the year 2008, what is the difference between the Number of teachers in High income: nonOECD and Number of teachers in Andorra?
Your answer should be compact. 1.23e+06. In the year 2008, what is the difference between the Number of teachers of High income: nonOECD and Number of teachers of Azerbaijan?
Offer a very short reply. 1.19e+06. In the year 2008, what is the difference between the Number of teachers of High income: nonOECD and Number of teachers of Mozambique?
Make the answer very short. 1.16e+06. In the year 2008, what is the difference between the Number of teachers in Andorra and Number of teachers in Azerbaijan?
Keep it short and to the point. -4.35e+04. In the year 2008, what is the difference between the Number of teachers of Andorra and Number of teachers of Mozambique?
Keep it short and to the point. -7.61e+04. In the year 2008, what is the difference between the Number of teachers in Azerbaijan and Number of teachers in Mozambique?
Your answer should be compact. -3.26e+04. In the year 2009, what is the difference between the Number of teachers in High income: nonOECD and Number of teachers in Andorra?
Provide a short and direct response. 1.23e+06. In the year 2009, what is the difference between the Number of teachers of High income: nonOECD and Number of teachers of Azerbaijan?
Offer a very short reply. 1.18e+06. In the year 2009, what is the difference between the Number of teachers of High income: nonOECD and Number of teachers of Mozambique?
Provide a succinct answer. 1.14e+06. In the year 2009, what is the difference between the Number of teachers in Andorra and Number of teachers in Azerbaijan?
Keep it short and to the point. -4.38e+04. In the year 2009, what is the difference between the Number of teachers in Andorra and Number of teachers in Mozambique?
Provide a succinct answer. -8.23e+04. In the year 2009, what is the difference between the Number of teachers of Azerbaijan and Number of teachers of Mozambique?
Give a very brief answer. -3.85e+04. In the year 2010, what is the difference between the Number of teachers in High income: nonOECD and Number of teachers in Andorra?
Provide a short and direct response. 1.24e+06. In the year 2010, what is the difference between the Number of teachers of High income: nonOECD and Number of teachers of Azerbaijan?
Offer a terse response. 1.20e+06. In the year 2010, what is the difference between the Number of teachers of High income: nonOECD and Number of teachers of Mozambique?
Your answer should be very brief. 1.16e+06. In the year 2010, what is the difference between the Number of teachers in Andorra and Number of teachers in Azerbaijan?
Offer a very short reply. -4.32e+04. In the year 2010, what is the difference between the Number of teachers of Andorra and Number of teachers of Mozambique?
Your answer should be compact. -8.98e+04. In the year 2010, what is the difference between the Number of teachers in Azerbaijan and Number of teachers in Mozambique?
Provide a short and direct response. -4.66e+04. In the year 2011, what is the difference between the Number of teachers of High income: nonOECD and Number of teachers of Andorra?
Your answer should be very brief. 1.25e+06. In the year 2011, what is the difference between the Number of teachers of High income: nonOECD and Number of teachers of Azerbaijan?
Your answer should be very brief. 1.21e+06. In the year 2011, what is the difference between the Number of teachers of High income: nonOECD and Number of teachers of Mozambique?
Provide a short and direct response. 1.16e+06. In the year 2011, what is the difference between the Number of teachers in Andorra and Number of teachers in Azerbaijan?
Your answer should be compact. -4.28e+04. In the year 2011, what is the difference between the Number of teachers of Andorra and Number of teachers of Mozambique?
Offer a terse response. -9.44e+04. In the year 2011, what is the difference between the Number of teachers of Azerbaijan and Number of teachers of Mozambique?
Make the answer very short. -5.16e+04. What is the ratio of the Number of teachers in High income: nonOECD in 2004 to that in 2005?
Ensure brevity in your answer.  1.02. What is the ratio of the Number of teachers in Andorra in 2004 to that in 2005?
Offer a very short reply. 0.95. What is the ratio of the Number of teachers in Azerbaijan in 2004 to that in 2005?
Make the answer very short. 1.01. What is the ratio of the Number of teachers of Mozambique in 2004 to that in 2005?
Give a very brief answer. 0.92. What is the ratio of the Number of teachers of High income: nonOECD in 2004 to that in 2006?
Your answer should be very brief. 1.02. What is the ratio of the Number of teachers in Andorra in 2004 to that in 2006?
Ensure brevity in your answer.  0.82. What is the ratio of the Number of teachers of Mozambique in 2004 to that in 2006?
Provide a succinct answer. 0.88. What is the ratio of the Number of teachers of Andorra in 2004 to that in 2007?
Ensure brevity in your answer.  0.78. What is the ratio of the Number of teachers of Mozambique in 2004 to that in 2007?
Offer a very short reply. 0.78. What is the ratio of the Number of teachers in High income: nonOECD in 2004 to that in 2008?
Keep it short and to the point. 1.01. What is the ratio of the Number of teachers in Andorra in 2004 to that in 2008?
Keep it short and to the point. 0.75. What is the ratio of the Number of teachers of Azerbaijan in 2004 to that in 2008?
Your answer should be very brief. 0.97. What is the ratio of the Number of teachers in Mozambique in 2004 to that in 2008?
Your response must be concise. 0.71. What is the ratio of the Number of teachers in High income: nonOECD in 2004 to that in 2009?
Provide a succinct answer. 1.01. What is the ratio of the Number of teachers of Andorra in 2004 to that in 2009?
Your answer should be very brief. 0.78. What is the ratio of the Number of teachers in Azerbaijan in 2004 to that in 2009?
Offer a very short reply. 0.96. What is the ratio of the Number of teachers in Mozambique in 2004 to that in 2009?
Make the answer very short. 0.66. What is the ratio of the Number of teachers of High income: nonOECD in 2004 to that in 2010?
Offer a very short reply. 1. What is the ratio of the Number of teachers in Andorra in 2004 to that in 2010?
Your answer should be very brief. 0.74. What is the ratio of the Number of teachers in Azerbaijan in 2004 to that in 2010?
Your answer should be compact. 0.98. What is the ratio of the Number of teachers in Mozambique in 2004 to that in 2010?
Your answer should be compact. 0.61. What is the ratio of the Number of teachers of Andorra in 2004 to that in 2011?
Provide a short and direct response. 0.78. What is the ratio of the Number of teachers of Azerbaijan in 2004 to that in 2011?
Ensure brevity in your answer.  0.98. What is the ratio of the Number of teachers in Mozambique in 2004 to that in 2011?
Make the answer very short. 0.58. What is the ratio of the Number of teachers of Andorra in 2005 to that in 2006?
Your answer should be compact. 0.86. What is the ratio of the Number of teachers in Azerbaijan in 2005 to that in 2006?
Ensure brevity in your answer.  0.98. What is the ratio of the Number of teachers of Mozambique in 2005 to that in 2006?
Offer a terse response. 0.96. What is the ratio of the Number of teachers of High income: nonOECD in 2005 to that in 2007?
Make the answer very short. 0.98. What is the ratio of the Number of teachers in Andorra in 2005 to that in 2007?
Give a very brief answer. 0.82. What is the ratio of the Number of teachers of Azerbaijan in 2005 to that in 2007?
Offer a very short reply. 0.96. What is the ratio of the Number of teachers in Mozambique in 2005 to that in 2007?
Your response must be concise. 0.84. What is the ratio of the Number of teachers of High income: nonOECD in 2005 to that in 2008?
Your answer should be very brief. 0.98. What is the ratio of the Number of teachers in Andorra in 2005 to that in 2008?
Your answer should be very brief. 0.79. What is the ratio of the Number of teachers of Azerbaijan in 2005 to that in 2008?
Give a very brief answer. 0.96. What is the ratio of the Number of teachers in Mozambique in 2005 to that in 2008?
Offer a very short reply. 0.78. What is the ratio of the Number of teachers in Andorra in 2005 to that in 2009?
Offer a very short reply. 0.82. What is the ratio of the Number of teachers of Azerbaijan in 2005 to that in 2009?
Offer a terse response. 0.95. What is the ratio of the Number of teachers of Mozambique in 2005 to that in 2009?
Make the answer very short. 0.72. What is the ratio of the Number of teachers in High income: nonOECD in 2005 to that in 2010?
Make the answer very short. 0.97. What is the ratio of the Number of teachers of Andorra in 2005 to that in 2010?
Your response must be concise. 0.79. What is the ratio of the Number of teachers of Azerbaijan in 2005 to that in 2010?
Offer a terse response. 0.97. What is the ratio of the Number of teachers of Mozambique in 2005 to that in 2010?
Provide a short and direct response. 0.66. What is the ratio of the Number of teachers in High income: nonOECD in 2005 to that in 2011?
Make the answer very short. 0.97. What is the ratio of the Number of teachers in Andorra in 2005 to that in 2011?
Your answer should be compact. 0.82. What is the ratio of the Number of teachers in Azerbaijan in 2005 to that in 2011?
Your answer should be very brief. 0.98. What is the ratio of the Number of teachers in Mozambique in 2005 to that in 2011?
Offer a very short reply. 0.63. What is the ratio of the Number of teachers in High income: nonOECD in 2006 to that in 2007?
Keep it short and to the point. 0.98. What is the ratio of the Number of teachers in Andorra in 2006 to that in 2007?
Provide a short and direct response. 0.96. What is the ratio of the Number of teachers in Azerbaijan in 2006 to that in 2007?
Your answer should be very brief. 0.98. What is the ratio of the Number of teachers of Mozambique in 2006 to that in 2007?
Provide a short and direct response. 0.88. What is the ratio of the Number of teachers of Andorra in 2006 to that in 2008?
Keep it short and to the point. 0.92. What is the ratio of the Number of teachers of Azerbaijan in 2006 to that in 2008?
Make the answer very short. 0.98. What is the ratio of the Number of teachers in Mozambique in 2006 to that in 2008?
Make the answer very short. 0.81. What is the ratio of the Number of teachers in High income: nonOECD in 2006 to that in 2009?
Ensure brevity in your answer.  1. What is the ratio of the Number of teachers of Andorra in 2006 to that in 2009?
Your answer should be compact. 0.95. What is the ratio of the Number of teachers of Azerbaijan in 2006 to that in 2009?
Provide a short and direct response. 0.97. What is the ratio of the Number of teachers in Mozambique in 2006 to that in 2009?
Provide a short and direct response. 0.75. What is the ratio of the Number of teachers of High income: nonOECD in 2006 to that in 2010?
Offer a very short reply. 0.98. What is the ratio of the Number of teachers of Andorra in 2006 to that in 2010?
Offer a very short reply. 0.91. What is the ratio of the Number of teachers of Azerbaijan in 2006 to that in 2010?
Give a very brief answer. 0.99. What is the ratio of the Number of teachers of Mozambique in 2006 to that in 2010?
Your answer should be very brief. 0.69. What is the ratio of the Number of teachers of High income: nonOECD in 2006 to that in 2011?
Your answer should be very brief. 0.97. What is the ratio of the Number of teachers in Andorra in 2006 to that in 2011?
Ensure brevity in your answer.  0.95. What is the ratio of the Number of teachers in Mozambique in 2006 to that in 2011?
Offer a very short reply. 0.65. What is the ratio of the Number of teachers in High income: nonOECD in 2007 to that in 2008?
Make the answer very short. 1. What is the ratio of the Number of teachers in Mozambique in 2007 to that in 2008?
Ensure brevity in your answer.  0.92. What is the ratio of the Number of teachers of High income: nonOECD in 2007 to that in 2009?
Give a very brief answer. 1.01. What is the ratio of the Number of teachers of Mozambique in 2007 to that in 2009?
Your answer should be very brief. 0.85. What is the ratio of the Number of teachers of High income: nonOECD in 2007 to that in 2010?
Make the answer very short. 1. What is the ratio of the Number of teachers in Andorra in 2007 to that in 2010?
Ensure brevity in your answer.  0.95. What is the ratio of the Number of teachers in Azerbaijan in 2007 to that in 2010?
Give a very brief answer. 1.01. What is the ratio of the Number of teachers in Mozambique in 2007 to that in 2010?
Keep it short and to the point. 0.78. What is the ratio of the Number of teachers in High income: nonOECD in 2007 to that in 2011?
Offer a very short reply. 0.99. What is the ratio of the Number of teachers of Andorra in 2007 to that in 2011?
Make the answer very short. 1. What is the ratio of the Number of teachers in Mozambique in 2007 to that in 2011?
Ensure brevity in your answer.  0.74. What is the ratio of the Number of teachers of High income: nonOECD in 2008 to that in 2009?
Your answer should be very brief. 1.01. What is the ratio of the Number of teachers in Andorra in 2008 to that in 2009?
Ensure brevity in your answer.  1.03. What is the ratio of the Number of teachers of Mozambique in 2008 to that in 2009?
Your response must be concise. 0.93. What is the ratio of the Number of teachers of High income: nonOECD in 2008 to that in 2010?
Give a very brief answer. 0.99. What is the ratio of the Number of teachers in Andorra in 2008 to that in 2010?
Give a very brief answer. 0.99. What is the ratio of the Number of teachers of Azerbaijan in 2008 to that in 2010?
Provide a succinct answer. 1.01. What is the ratio of the Number of teachers in Mozambique in 2008 to that in 2010?
Provide a short and direct response. 0.85. What is the ratio of the Number of teachers in High income: nonOECD in 2008 to that in 2011?
Keep it short and to the point. 0.98. What is the ratio of the Number of teachers of Andorra in 2008 to that in 2011?
Your answer should be very brief. 1.03. What is the ratio of the Number of teachers of Azerbaijan in 2008 to that in 2011?
Your answer should be compact. 1.02. What is the ratio of the Number of teachers of Mozambique in 2008 to that in 2011?
Your answer should be very brief. 0.81. What is the ratio of the Number of teachers of High income: nonOECD in 2009 to that in 2010?
Your response must be concise. 0.98. What is the ratio of the Number of teachers of Andorra in 2009 to that in 2010?
Provide a succinct answer. 0.96. What is the ratio of the Number of teachers in Azerbaijan in 2009 to that in 2010?
Ensure brevity in your answer.  1.01. What is the ratio of the Number of teachers in Mozambique in 2009 to that in 2010?
Offer a very short reply. 0.92. What is the ratio of the Number of teachers in High income: nonOECD in 2009 to that in 2011?
Give a very brief answer. 0.98. What is the ratio of the Number of teachers in Andorra in 2009 to that in 2011?
Your answer should be very brief. 1. What is the ratio of the Number of teachers in Azerbaijan in 2009 to that in 2011?
Provide a short and direct response. 1.02. What is the ratio of the Number of teachers of Mozambique in 2009 to that in 2011?
Make the answer very short. 0.87. What is the ratio of the Number of teachers in High income: nonOECD in 2010 to that in 2011?
Provide a short and direct response. 0.99. What is the ratio of the Number of teachers in Andorra in 2010 to that in 2011?
Provide a succinct answer. 1.05. What is the ratio of the Number of teachers in Azerbaijan in 2010 to that in 2011?
Keep it short and to the point. 1.01. What is the ratio of the Number of teachers of Mozambique in 2010 to that in 2011?
Your answer should be compact. 0.95. What is the difference between the highest and the second highest Number of teachers in High income: nonOECD?
Your answer should be very brief. 9480.25. What is the difference between the highest and the second highest Number of teachers in Andorra?
Make the answer very short. 5. What is the difference between the highest and the second highest Number of teachers of Azerbaijan?
Give a very brief answer. 126. What is the difference between the highest and the second highest Number of teachers in Mozambique?
Provide a succinct answer. 4562. What is the difference between the highest and the lowest Number of teachers of High income: nonOECD?
Provide a short and direct response. 4.15e+04. What is the difference between the highest and the lowest Number of teachers in Andorra?
Ensure brevity in your answer.  116. What is the difference between the highest and the lowest Number of teachers in Azerbaijan?
Provide a succinct answer. 1989. What is the difference between the highest and the lowest Number of teachers in Mozambique?
Ensure brevity in your answer.  4.01e+04. 